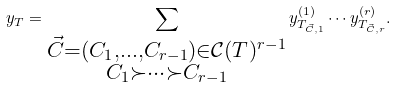Convert formula to latex. <formula><loc_0><loc_0><loc_500><loc_500>y _ { T } = \sum _ { \substack { \vec { C } = ( C _ { 1 } , \dots , C _ { r - 1 } ) \in { \mathcal { C } } ( T ) ^ { r - 1 } \\ C _ { 1 } \succ \cdots \succ C _ { r - 1 } } } y _ { T _ { \vec { C } , 1 } } ^ { ( 1 ) } \cdots y _ { T _ { \vec { C } , r } } ^ { ( r ) } .</formula> 